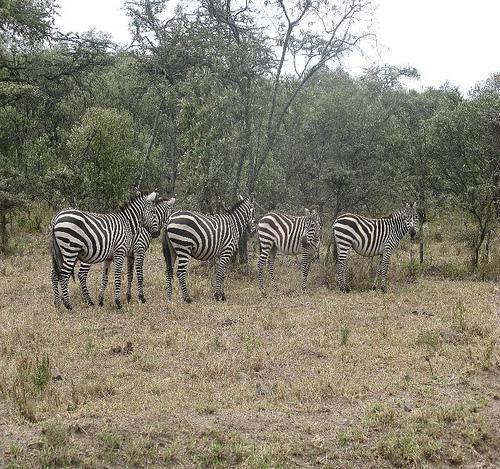How many zebras are shown?
Give a very brief answer. 5. How many zebras?
Give a very brief answer. 4. How many animals are in the field?
Give a very brief answer. 4. How many  zebras  are there?
Give a very brief answer. 4. How many animals are there?
Give a very brief answer. 4. How many zebras are visible?
Give a very brief answer. 4. 